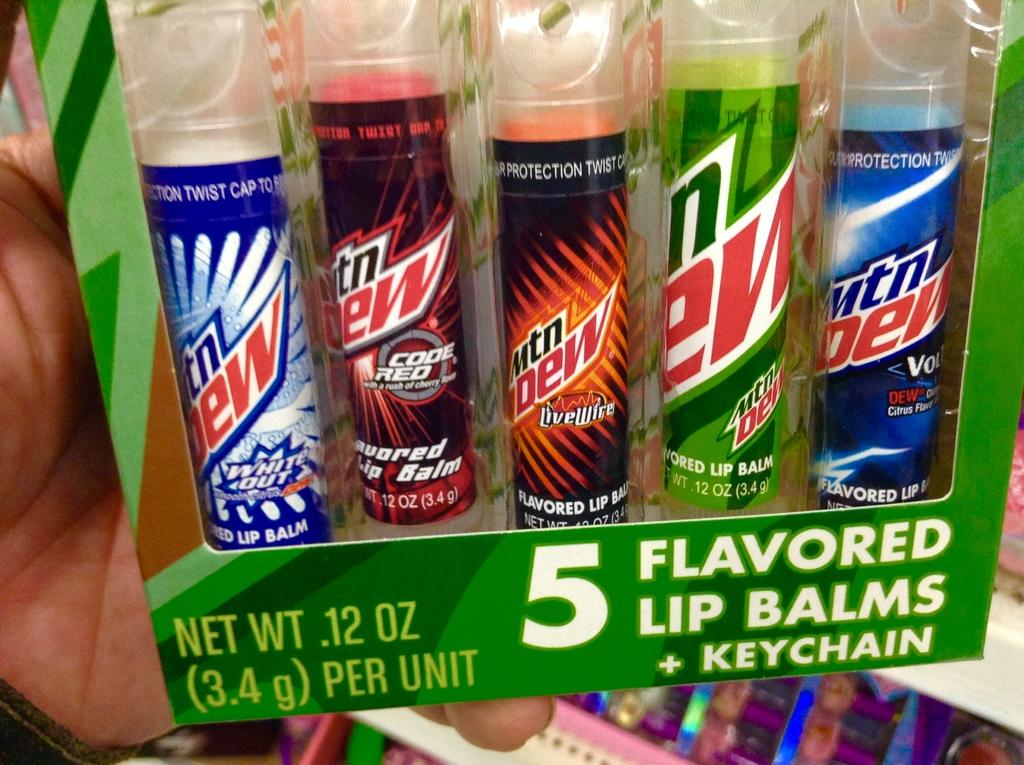<image>
Write a terse but informative summary of the picture. Mountain new bottles that says "3.4 g" on the box. 